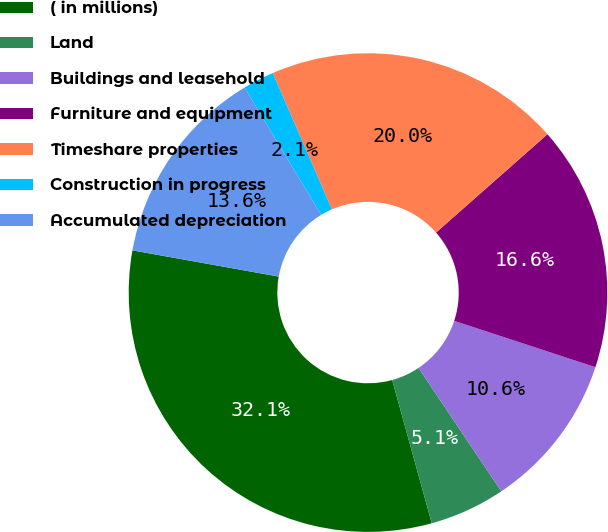Convert chart. <chart><loc_0><loc_0><loc_500><loc_500><pie_chart><fcel>( in millions)<fcel>Land<fcel>Buildings and leasehold<fcel>Furniture and equipment<fcel>Timeshare properties<fcel>Construction in progress<fcel>Accumulated depreciation<nl><fcel>32.11%<fcel>5.11%<fcel>10.55%<fcel>16.55%<fcel>20.0%<fcel>2.11%<fcel>13.55%<nl></chart> 